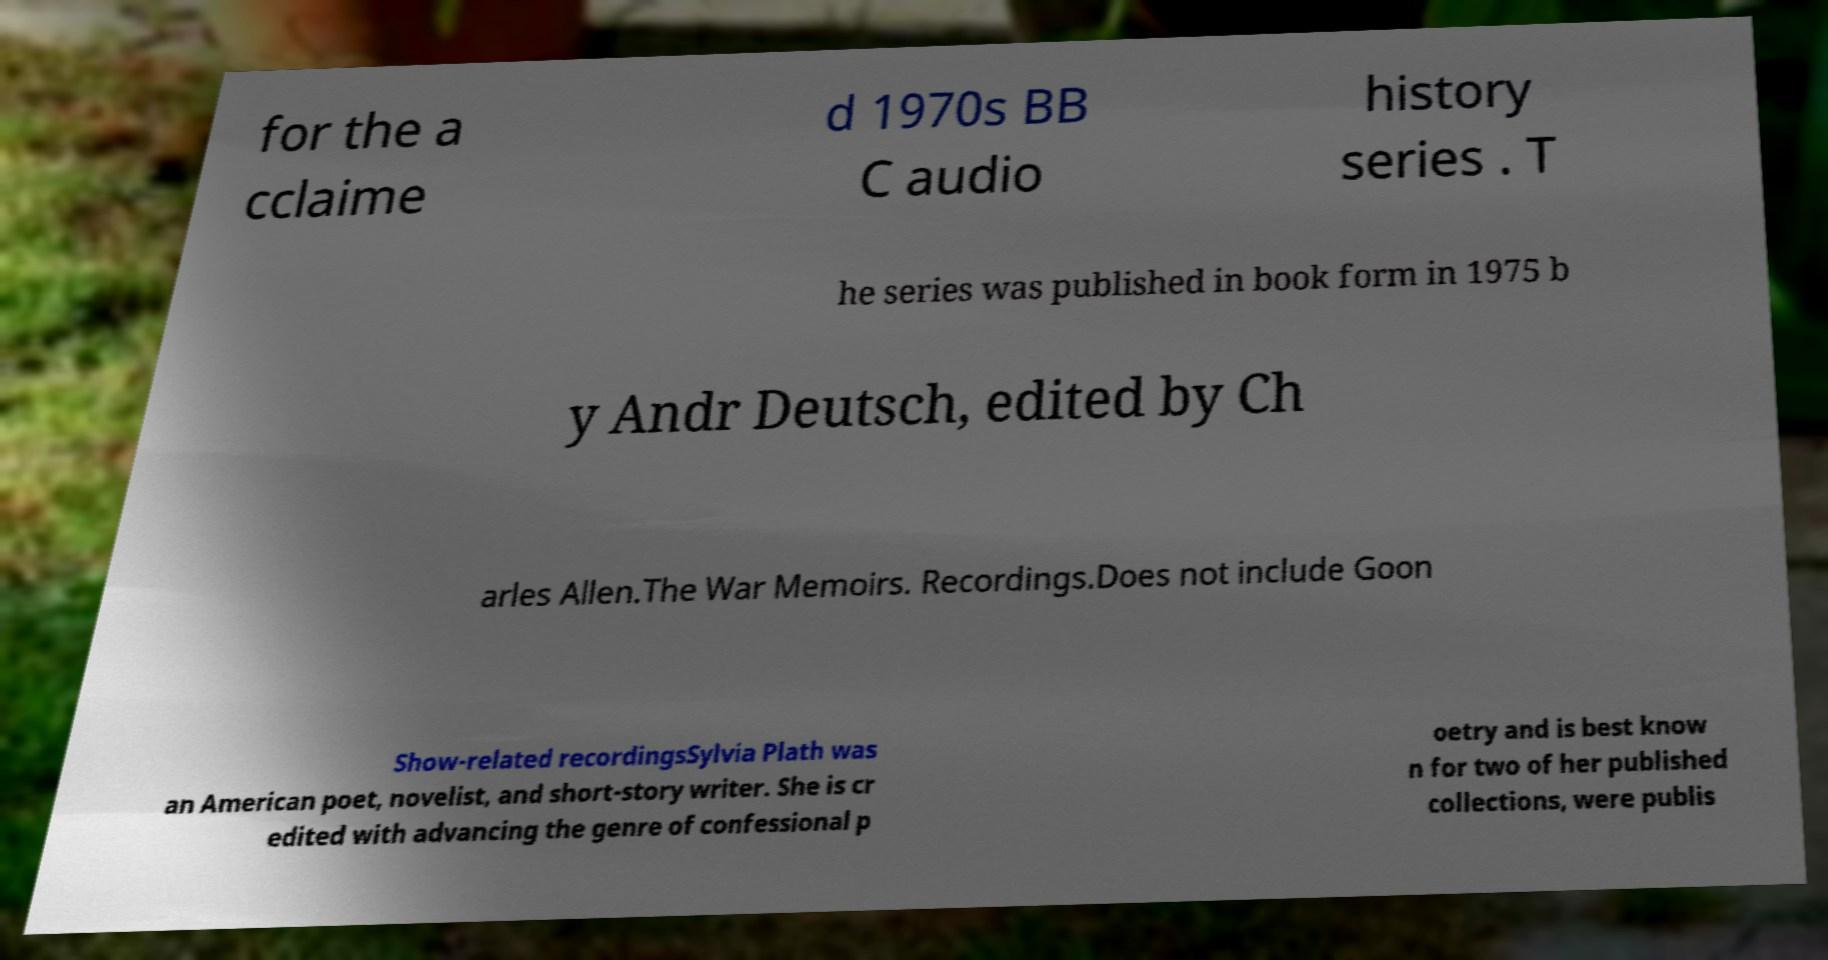I need the written content from this picture converted into text. Can you do that? for the a cclaime d 1970s BB C audio history series . T he series was published in book form in 1975 b y Andr Deutsch, edited by Ch arles Allen.The War Memoirs. Recordings.Does not include Goon Show-related recordingsSylvia Plath was an American poet, novelist, and short-story writer. She is cr edited with advancing the genre of confessional p oetry and is best know n for two of her published collections, were publis 